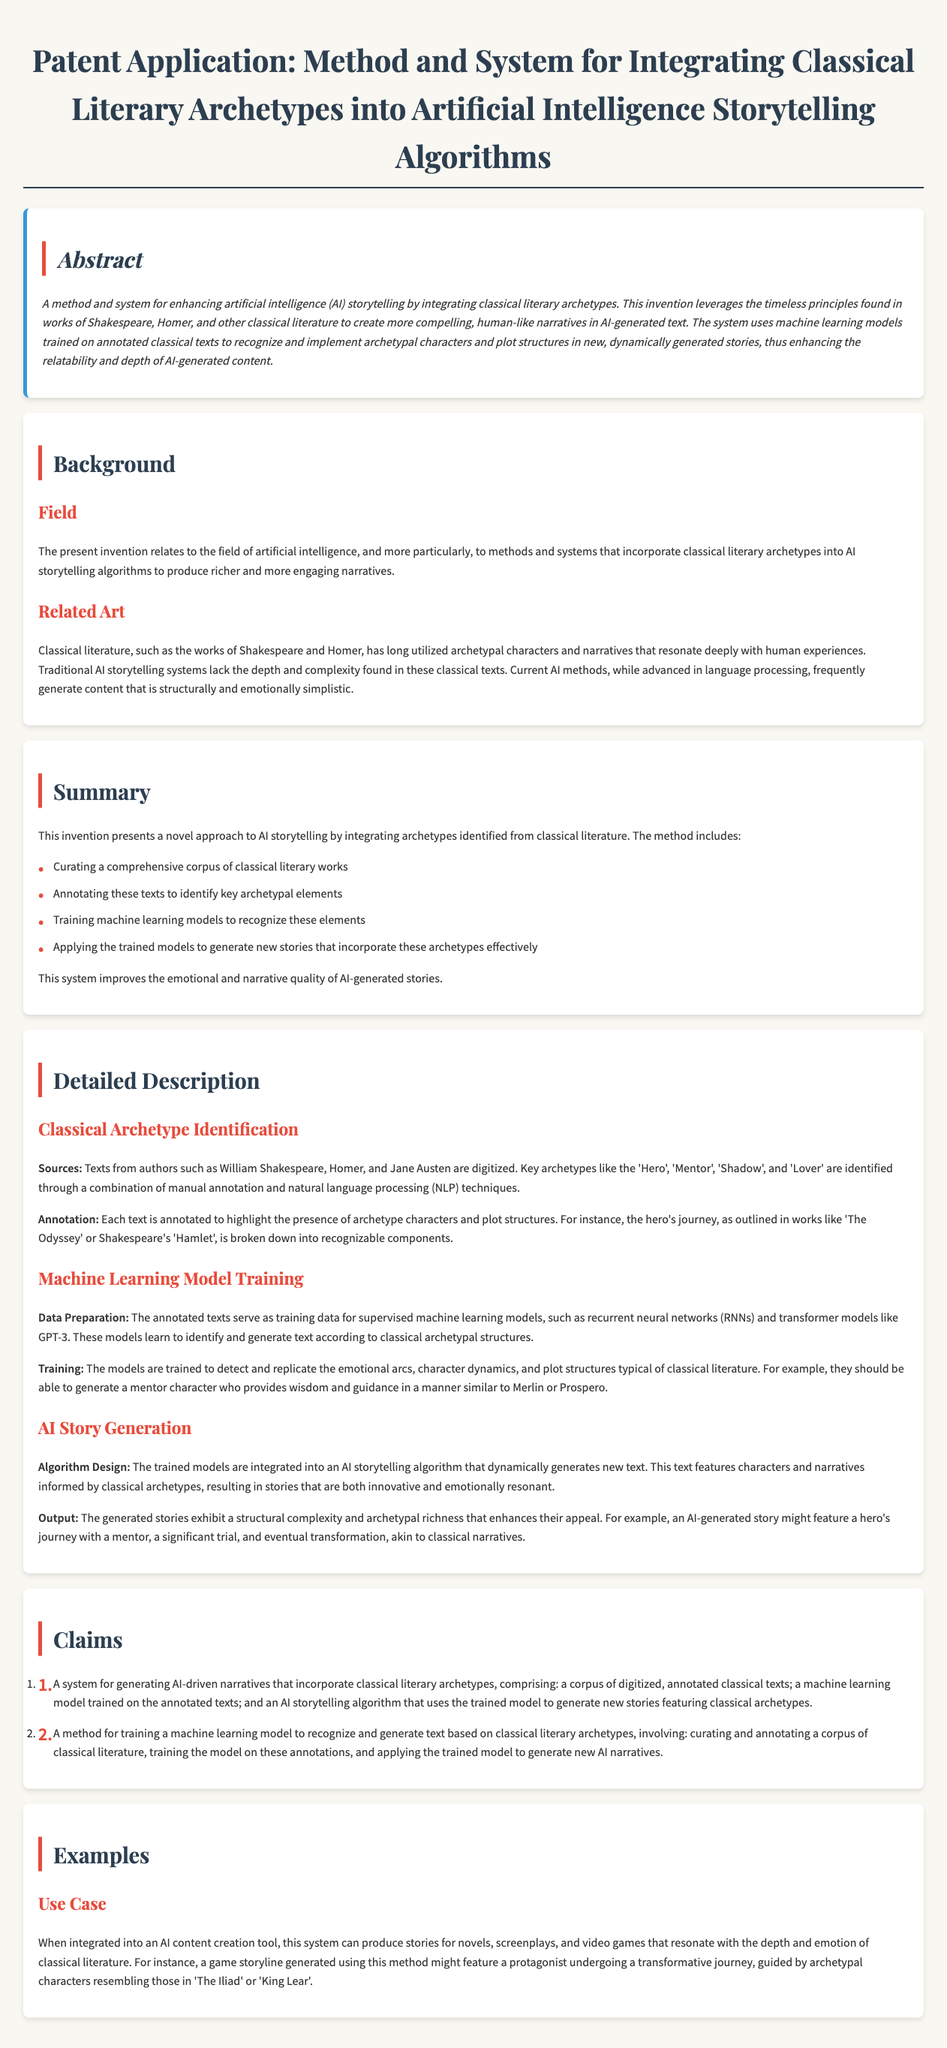What is the main purpose of the invention? The invention aims to enhance AI storytelling by integrating classical literary archetypes.
Answer: Enhance AI storytelling Who are the classical authors mentioned in the document? The document references Shakespeare, Homer, and Jane Austen as sources of classical literature.
Answer: Shakespeare, Homer, Jane Austen What method is used for archetype identification? The identification of archetypes involves manual annotation and natural language processing techniques.
Answer: Manual annotation and natural language processing What does the machine learning model train on? The machine learning model is trained on annotated texts that highlight archetype characters and plot structures.
Answer: Annotated texts Name one archetypal character mentioned in the document. The document references the 'Hero' as one of the key archetypal characters.
Answer: Hero What is a potential output of the AI storytelling algorithm? The output includes stories featuring characters and narratives informed by classical archetypes.
Answer: Stories featuring characters and narratives How many claims are listed in the patent application? There are two claims outlined in the patent application document.
Answer: Two What is a use case mentioned for this system? The system can be used in an AI content creation tool for generating stories for novels and screenplays.
Answer: Generating stories for novels and screenplays 